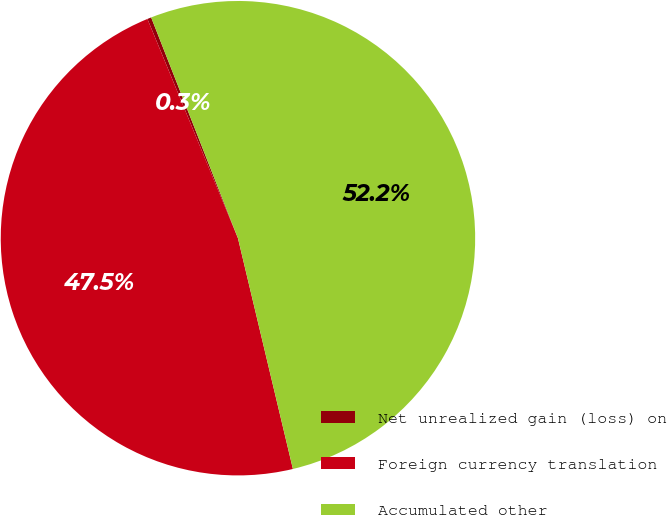<chart> <loc_0><loc_0><loc_500><loc_500><pie_chart><fcel>Net unrealized gain (loss) on<fcel>Foreign currency translation<fcel>Accumulated other<nl><fcel>0.27%<fcel>47.49%<fcel>52.24%<nl></chart> 